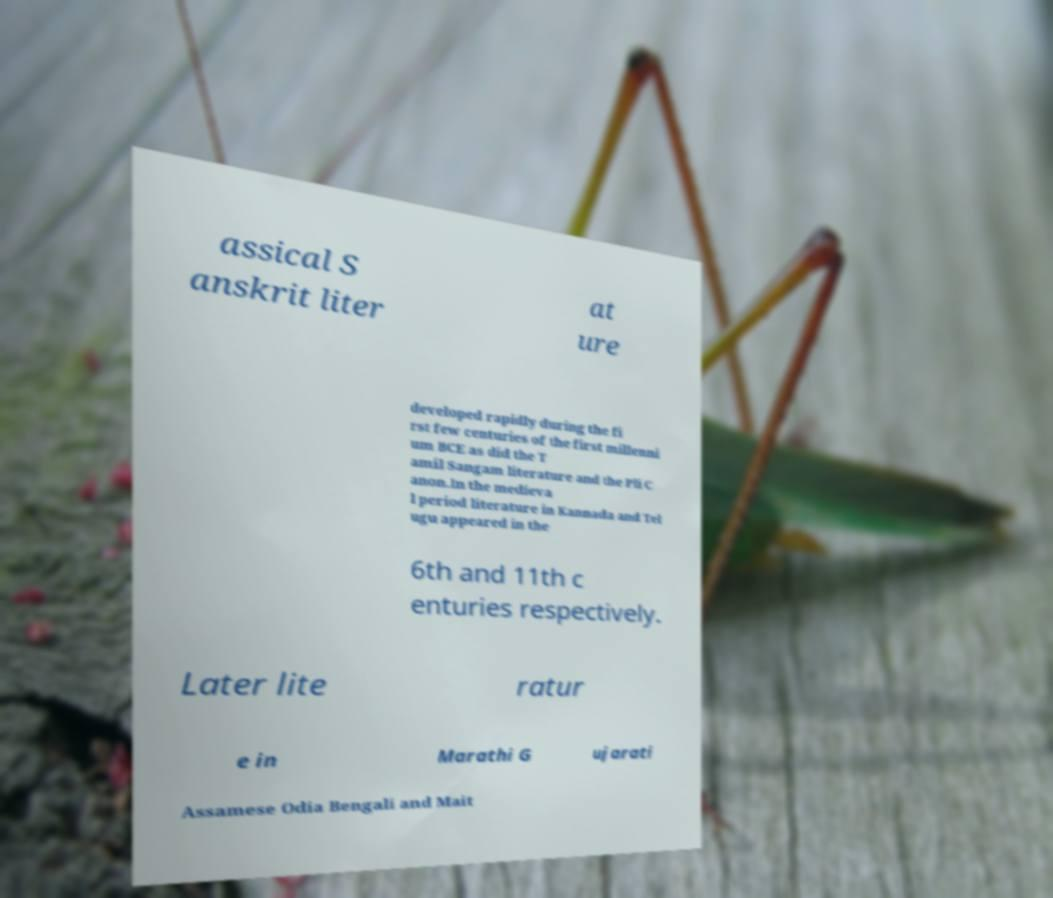Could you extract and type out the text from this image? assical S anskrit liter at ure developed rapidly during the fi rst few centuries of the first millenni um BCE as did the T amil Sangam literature and the Pli C anon.In the medieva l period literature in Kannada and Tel ugu appeared in the 6th and 11th c enturies respectively. Later lite ratur e in Marathi G ujarati Assamese Odia Bengali and Mait 